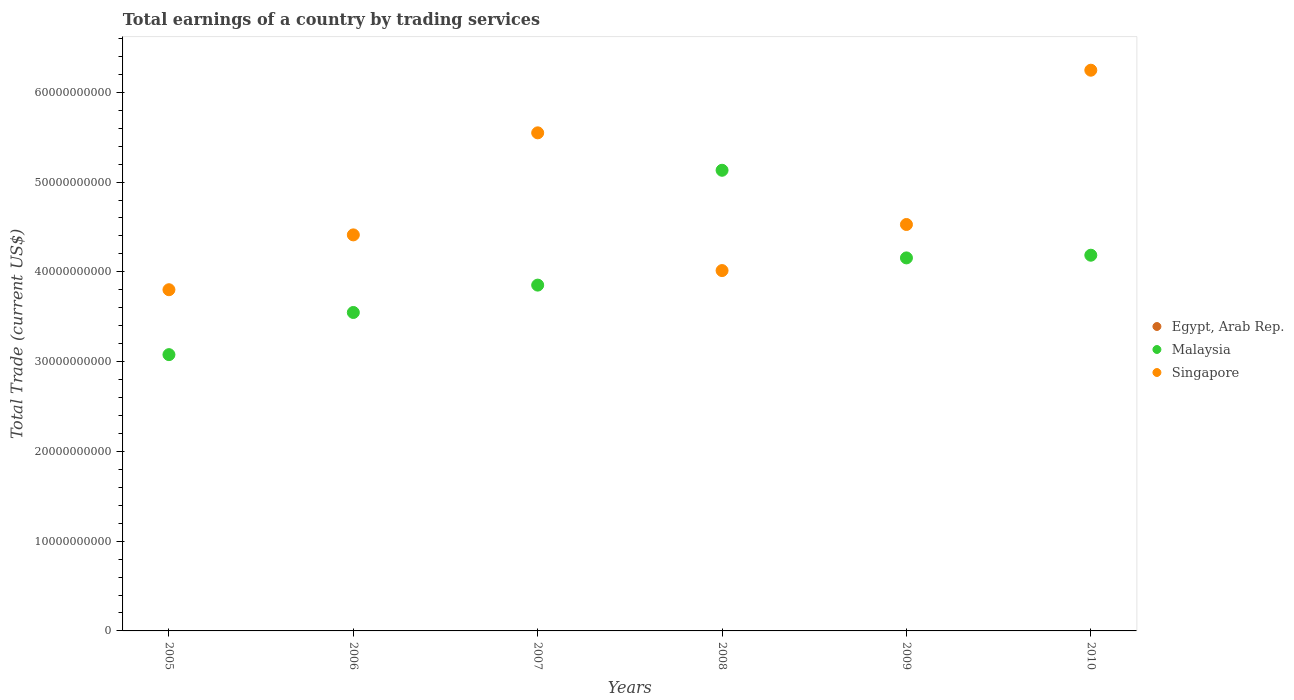How many different coloured dotlines are there?
Provide a succinct answer. 2. Across all years, what is the maximum total earnings in Malaysia?
Ensure brevity in your answer.  5.13e+1. Across all years, what is the minimum total earnings in Malaysia?
Offer a very short reply. 3.08e+1. What is the total total earnings in Singapore in the graph?
Offer a terse response. 2.85e+11. What is the difference between the total earnings in Malaysia in 2005 and that in 2007?
Provide a succinct answer. -7.74e+09. What is the difference between the total earnings in Malaysia in 2010 and the total earnings in Singapore in 2007?
Make the answer very short. -1.36e+1. What is the average total earnings in Singapore per year?
Offer a terse response. 4.76e+1. In the year 2008, what is the difference between the total earnings in Malaysia and total earnings in Singapore?
Provide a succinct answer. 1.12e+1. What is the ratio of the total earnings in Malaysia in 2006 to that in 2009?
Provide a succinct answer. 0.85. What is the difference between the highest and the second highest total earnings in Singapore?
Provide a short and direct response. 6.98e+09. What is the difference between the highest and the lowest total earnings in Malaysia?
Offer a very short reply. 2.05e+1. In how many years, is the total earnings in Singapore greater than the average total earnings in Singapore taken over all years?
Ensure brevity in your answer.  2. Is the sum of the total earnings in Singapore in 2005 and 2009 greater than the maximum total earnings in Malaysia across all years?
Your response must be concise. Yes. Is it the case that in every year, the sum of the total earnings in Egypt, Arab Rep. and total earnings in Malaysia  is greater than the total earnings in Singapore?
Give a very brief answer. No. How many dotlines are there?
Keep it short and to the point. 2. What is the difference between two consecutive major ticks on the Y-axis?
Give a very brief answer. 1.00e+1. Are the values on the major ticks of Y-axis written in scientific E-notation?
Offer a terse response. No. Does the graph contain any zero values?
Offer a terse response. Yes. Where does the legend appear in the graph?
Provide a short and direct response. Center right. How are the legend labels stacked?
Ensure brevity in your answer.  Vertical. What is the title of the graph?
Keep it short and to the point. Total earnings of a country by trading services. Does "Lower middle income" appear as one of the legend labels in the graph?
Give a very brief answer. No. What is the label or title of the X-axis?
Ensure brevity in your answer.  Years. What is the label or title of the Y-axis?
Your answer should be compact. Total Trade (current US$). What is the Total Trade (current US$) of Egypt, Arab Rep. in 2005?
Your response must be concise. 0. What is the Total Trade (current US$) in Malaysia in 2005?
Offer a very short reply. 3.08e+1. What is the Total Trade (current US$) of Singapore in 2005?
Offer a terse response. 3.80e+1. What is the Total Trade (current US$) of Egypt, Arab Rep. in 2006?
Provide a succinct answer. 0. What is the Total Trade (current US$) of Malaysia in 2006?
Make the answer very short. 3.55e+1. What is the Total Trade (current US$) in Singapore in 2006?
Your answer should be compact. 4.41e+1. What is the Total Trade (current US$) of Egypt, Arab Rep. in 2007?
Offer a very short reply. 0. What is the Total Trade (current US$) in Malaysia in 2007?
Your answer should be compact. 3.85e+1. What is the Total Trade (current US$) of Singapore in 2007?
Keep it short and to the point. 5.55e+1. What is the Total Trade (current US$) in Egypt, Arab Rep. in 2008?
Your answer should be compact. 0. What is the Total Trade (current US$) in Malaysia in 2008?
Ensure brevity in your answer.  5.13e+1. What is the Total Trade (current US$) of Singapore in 2008?
Your answer should be compact. 4.01e+1. What is the Total Trade (current US$) in Egypt, Arab Rep. in 2009?
Keep it short and to the point. 0. What is the Total Trade (current US$) of Malaysia in 2009?
Your response must be concise. 4.16e+1. What is the Total Trade (current US$) in Singapore in 2009?
Your response must be concise. 4.53e+1. What is the Total Trade (current US$) in Egypt, Arab Rep. in 2010?
Your answer should be very brief. 0. What is the Total Trade (current US$) of Malaysia in 2010?
Your response must be concise. 4.19e+1. What is the Total Trade (current US$) in Singapore in 2010?
Ensure brevity in your answer.  6.25e+1. Across all years, what is the maximum Total Trade (current US$) in Malaysia?
Provide a succinct answer. 5.13e+1. Across all years, what is the maximum Total Trade (current US$) in Singapore?
Keep it short and to the point. 6.25e+1. Across all years, what is the minimum Total Trade (current US$) in Malaysia?
Your answer should be compact. 3.08e+1. Across all years, what is the minimum Total Trade (current US$) in Singapore?
Offer a terse response. 3.80e+1. What is the total Total Trade (current US$) of Malaysia in the graph?
Provide a short and direct response. 2.39e+11. What is the total Total Trade (current US$) in Singapore in the graph?
Ensure brevity in your answer.  2.85e+11. What is the difference between the Total Trade (current US$) of Malaysia in 2005 and that in 2006?
Provide a short and direct response. -4.70e+09. What is the difference between the Total Trade (current US$) in Singapore in 2005 and that in 2006?
Provide a short and direct response. -6.11e+09. What is the difference between the Total Trade (current US$) of Malaysia in 2005 and that in 2007?
Keep it short and to the point. -7.74e+09. What is the difference between the Total Trade (current US$) of Singapore in 2005 and that in 2007?
Your response must be concise. -1.75e+1. What is the difference between the Total Trade (current US$) in Malaysia in 2005 and that in 2008?
Provide a short and direct response. -2.05e+1. What is the difference between the Total Trade (current US$) of Singapore in 2005 and that in 2008?
Your answer should be very brief. -2.13e+09. What is the difference between the Total Trade (current US$) of Malaysia in 2005 and that in 2009?
Ensure brevity in your answer.  -1.08e+1. What is the difference between the Total Trade (current US$) in Singapore in 2005 and that in 2009?
Keep it short and to the point. -7.27e+09. What is the difference between the Total Trade (current US$) of Malaysia in 2005 and that in 2010?
Make the answer very short. -1.11e+1. What is the difference between the Total Trade (current US$) in Singapore in 2005 and that in 2010?
Make the answer very short. -2.45e+1. What is the difference between the Total Trade (current US$) of Malaysia in 2006 and that in 2007?
Ensure brevity in your answer.  -3.05e+09. What is the difference between the Total Trade (current US$) in Singapore in 2006 and that in 2007?
Ensure brevity in your answer.  -1.14e+1. What is the difference between the Total Trade (current US$) of Malaysia in 2006 and that in 2008?
Your answer should be compact. -1.58e+1. What is the difference between the Total Trade (current US$) of Singapore in 2006 and that in 2008?
Offer a terse response. 3.98e+09. What is the difference between the Total Trade (current US$) in Malaysia in 2006 and that in 2009?
Offer a very short reply. -6.08e+09. What is the difference between the Total Trade (current US$) in Singapore in 2006 and that in 2009?
Provide a short and direct response. -1.16e+09. What is the difference between the Total Trade (current US$) of Malaysia in 2006 and that in 2010?
Make the answer very short. -6.38e+09. What is the difference between the Total Trade (current US$) in Singapore in 2006 and that in 2010?
Provide a short and direct response. -1.83e+1. What is the difference between the Total Trade (current US$) of Malaysia in 2007 and that in 2008?
Offer a terse response. -1.28e+1. What is the difference between the Total Trade (current US$) of Singapore in 2007 and that in 2008?
Provide a short and direct response. 1.53e+1. What is the difference between the Total Trade (current US$) of Malaysia in 2007 and that in 2009?
Give a very brief answer. -3.03e+09. What is the difference between the Total Trade (current US$) of Singapore in 2007 and that in 2009?
Offer a terse response. 1.02e+1. What is the difference between the Total Trade (current US$) in Malaysia in 2007 and that in 2010?
Your response must be concise. -3.33e+09. What is the difference between the Total Trade (current US$) of Singapore in 2007 and that in 2010?
Ensure brevity in your answer.  -6.98e+09. What is the difference between the Total Trade (current US$) of Malaysia in 2008 and that in 2009?
Make the answer very short. 9.76e+09. What is the difference between the Total Trade (current US$) in Singapore in 2008 and that in 2009?
Keep it short and to the point. -5.13e+09. What is the difference between the Total Trade (current US$) in Malaysia in 2008 and that in 2010?
Make the answer very short. 9.46e+09. What is the difference between the Total Trade (current US$) of Singapore in 2008 and that in 2010?
Give a very brief answer. -2.23e+1. What is the difference between the Total Trade (current US$) of Malaysia in 2009 and that in 2010?
Offer a very short reply. -3.00e+08. What is the difference between the Total Trade (current US$) of Singapore in 2009 and that in 2010?
Your response must be concise. -1.72e+1. What is the difference between the Total Trade (current US$) in Malaysia in 2005 and the Total Trade (current US$) in Singapore in 2006?
Make the answer very short. -1.33e+1. What is the difference between the Total Trade (current US$) of Malaysia in 2005 and the Total Trade (current US$) of Singapore in 2007?
Ensure brevity in your answer.  -2.47e+1. What is the difference between the Total Trade (current US$) of Malaysia in 2005 and the Total Trade (current US$) of Singapore in 2008?
Ensure brevity in your answer.  -9.36e+09. What is the difference between the Total Trade (current US$) of Malaysia in 2005 and the Total Trade (current US$) of Singapore in 2009?
Make the answer very short. -1.45e+1. What is the difference between the Total Trade (current US$) of Malaysia in 2005 and the Total Trade (current US$) of Singapore in 2010?
Ensure brevity in your answer.  -3.17e+1. What is the difference between the Total Trade (current US$) of Malaysia in 2006 and the Total Trade (current US$) of Singapore in 2007?
Your answer should be compact. -2.00e+1. What is the difference between the Total Trade (current US$) in Malaysia in 2006 and the Total Trade (current US$) in Singapore in 2008?
Your response must be concise. -4.67e+09. What is the difference between the Total Trade (current US$) in Malaysia in 2006 and the Total Trade (current US$) in Singapore in 2009?
Keep it short and to the point. -9.80e+09. What is the difference between the Total Trade (current US$) of Malaysia in 2006 and the Total Trade (current US$) of Singapore in 2010?
Your answer should be compact. -2.70e+1. What is the difference between the Total Trade (current US$) in Malaysia in 2007 and the Total Trade (current US$) in Singapore in 2008?
Your response must be concise. -1.62e+09. What is the difference between the Total Trade (current US$) of Malaysia in 2007 and the Total Trade (current US$) of Singapore in 2009?
Provide a short and direct response. -6.75e+09. What is the difference between the Total Trade (current US$) of Malaysia in 2007 and the Total Trade (current US$) of Singapore in 2010?
Your response must be concise. -2.39e+1. What is the difference between the Total Trade (current US$) of Malaysia in 2008 and the Total Trade (current US$) of Singapore in 2009?
Offer a terse response. 6.04e+09. What is the difference between the Total Trade (current US$) in Malaysia in 2008 and the Total Trade (current US$) in Singapore in 2010?
Provide a short and direct response. -1.11e+1. What is the difference between the Total Trade (current US$) of Malaysia in 2009 and the Total Trade (current US$) of Singapore in 2010?
Provide a succinct answer. -2.09e+1. What is the average Total Trade (current US$) of Malaysia per year?
Offer a terse response. 3.99e+1. What is the average Total Trade (current US$) in Singapore per year?
Offer a very short reply. 4.76e+1. In the year 2005, what is the difference between the Total Trade (current US$) of Malaysia and Total Trade (current US$) of Singapore?
Your answer should be compact. -7.23e+09. In the year 2006, what is the difference between the Total Trade (current US$) in Malaysia and Total Trade (current US$) in Singapore?
Your answer should be compact. -8.64e+09. In the year 2007, what is the difference between the Total Trade (current US$) of Malaysia and Total Trade (current US$) of Singapore?
Keep it short and to the point. -1.70e+1. In the year 2008, what is the difference between the Total Trade (current US$) in Malaysia and Total Trade (current US$) in Singapore?
Your response must be concise. 1.12e+1. In the year 2009, what is the difference between the Total Trade (current US$) in Malaysia and Total Trade (current US$) in Singapore?
Ensure brevity in your answer.  -3.72e+09. In the year 2010, what is the difference between the Total Trade (current US$) in Malaysia and Total Trade (current US$) in Singapore?
Your answer should be compact. -2.06e+1. What is the ratio of the Total Trade (current US$) of Malaysia in 2005 to that in 2006?
Make the answer very short. 0.87. What is the ratio of the Total Trade (current US$) of Singapore in 2005 to that in 2006?
Provide a short and direct response. 0.86. What is the ratio of the Total Trade (current US$) of Malaysia in 2005 to that in 2007?
Offer a terse response. 0.8. What is the ratio of the Total Trade (current US$) of Singapore in 2005 to that in 2007?
Your answer should be compact. 0.69. What is the ratio of the Total Trade (current US$) in Malaysia in 2005 to that in 2008?
Provide a short and direct response. 0.6. What is the ratio of the Total Trade (current US$) of Singapore in 2005 to that in 2008?
Provide a short and direct response. 0.95. What is the ratio of the Total Trade (current US$) of Malaysia in 2005 to that in 2009?
Your answer should be very brief. 0.74. What is the ratio of the Total Trade (current US$) in Singapore in 2005 to that in 2009?
Offer a very short reply. 0.84. What is the ratio of the Total Trade (current US$) in Malaysia in 2005 to that in 2010?
Provide a short and direct response. 0.74. What is the ratio of the Total Trade (current US$) of Singapore in 2005 to that in 2010?
Give a very brief answer. 0.61. What is the ratio of the Total Trade (current US$) of Malaysia in 2006 to that in 2007?
Offer a very short reply. 0.92. What is the ratio of the Total Trade (current US$) in Singapore in 2006 to that in 2007?
Offer a very short reply. 0.8. What is the ratio of the Total Trade (current US$) of Malaysia in 2006 to that in 2008?
Provide a succinct answer. 0.69. What is the ratio of the Total Trade (current US$) of Singapore in 2006 to that in 2008?
Make the answer very short. 1.1. What is the ratio of the Total Trade (current US$) of Malaysia in 2006 to that in 2009?
Provide a succinct answer. 0.85. What is the ratio of the Total Trade (current US$) of Singapore in 2006 to that in 2009?
Make the answer very short. 0.97. What is the ratio of the Total Trade (current US$) of Malaysia in 2006 to that in 2010?
Provide a short and direct response. 0.85. What is the ratio of the Total Trade (current US$) in Singapore in 2006 to that in 2010?
Provide a short and direct response. 0.71. What is the ratio of the Total Trade (current US$) of Malaysia in 2007 to that in 2008?
Give a very brief answer. 0.75. What is the ratio of the Total Trade (current US$) of Singapore in 2007 to that in 2008?
Keep it short and to the point. 1.38. What is the ratio of the Total Trade (current US$) of Malaysia in 2007 to that in 2009?
Make the answer very short. 0.93. What is the ratio of the Total Trade (current US$) of Singapore in 2007 to that in 2009?
Provide a succinct answer. 1.23. What is the ratio of the Total Trade (current US$) of Malaysia in 2007 to that in 2010?
Offer a very short reply. 0.92. What is the ratio of the Total Trade (current US$) in Singapore in 2007 to that in 2010?
Give a very brief answer. 0.89. What is the ratio of the Total Trade (current US$) in Malaysia in 2008 to that in 2009?
Keep it short and to the point. 1.23. What is the ratio of the Total Trade (current US$) of Singapore in 2008 to that in 2009?
Offer a very short reply. 0.89. What is the ratio of the Total Trade (current US$) of Malaysia in 2008 to that in 2010?
Ensure brevity in your answer.  1.23. What is the ratio of the Total Trade (current US$) of Singapore in 2008 to that in 2010?
Keep it short and to the point. 0.64. What is the ratio of the Total Trade (current US$) in Singapore in 2009 to that in 2010?
Give a very brief answer. 0.72. What is the difference between the highest and the second highest Total Trade (current US$) of Malaysia?
Give a very brief answer. 9.46e+09. What is the difference between the highest and the second highest Total Trade (current US$) of Singapore?
Your response must be concise. 6.98e+09. What is the difference between the highest and the lowest Total Trade (current US$) of Malaysia?
Provide a short and direct response. 2.05e+1. What is the difference between the highest and the lowest Total Trade (current US$) in Singapore?
Offer a very short reply. 2.45e+1. 